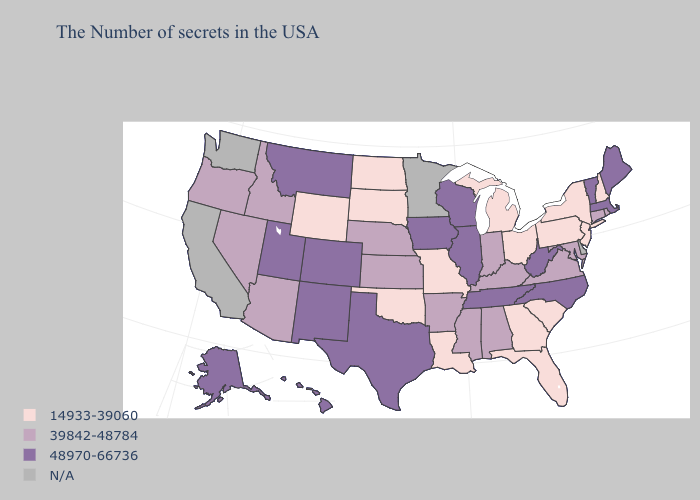Name the states that have a value in the range 14933-39060?
Give a very brief answer. New Hampshire, New York, New Jersey, Pennsylvania, South Carolina, Ohio, Florida, Georgia, Michigan, Louisiana, Missouri, Oklahoma, South Dakota, North Dakota, Wyoming. Name the states that have a value in the range 14933-39060?
Concise answer only. New Hampshire, New York, New Jersey, Pennsylvania, South Carolina, Ohio, Florida, Georgia, Michigan, Louisiana, Missouri, Oklahoma, South Dakota, North Dakota, Wyoming. Name the states that have a value in the range 39842-48784?
Short answer required. Rhode Island, Connecticut, Maryland, Virginia, Kentucky, Indiana, Alabama, Mississippi, Arkansas, Kansas, Nebraska, Arizona, Idaho, Nevada, Oregon. Which states have the highest value in the USA?
Concise answer only. Maine, Massachusetts, Vermont, North Carolina, West Virginia, Tennessee, Wisconsin, Illinois, Iowa, Texas, Colorado, New Mexico, Utah, Montana, Alaska, Hawaii. Does Pennsylvania have the highest value in the Northeast?
Write a very short answer. No. What is the value of Indiana?
Be succinct. 39842-48784. Among the states that border Kansas , does Colorado have the highest value?
Be succinct. Yes. What is the value of Pennsylvania?
Write a very short answer. 14933-39060. Does the map have missing data?
Concise answer only. Yes. What is the value of Maryland?
Concise answer only. 39842-48784. What is the value of Pennsylvania?
Give a very brief answer. 14933-39060. Does the first symbol in the legend represent the smallest category?
Write a very short answer. Yes. What is the value of North Dakota?
Quick response, please. 14933-39060. Does South Carolina have the lowest value in the USA?
Write a very short answer. Yes. 